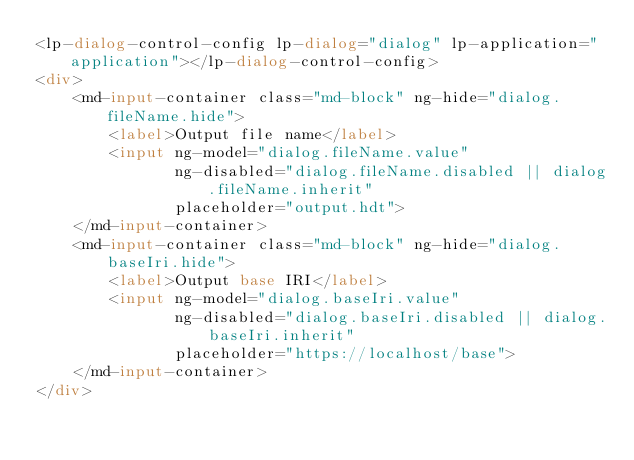<code> <loc_0><loc_0><loc_500><loc_500><_HTML_><lp-dialog-control-config lp-dialog="dialog" lp-application="application"></lp-dialog-control-config>
<div>
    <md-input-container class="md-block" ng-hide="dialog.fileName.hide">
        <label>Output file name</label>
        <input ng-model="dialog.fileName.value"
               ng-disabled="dialog.fileName.disabled || dialog.fileName.inherit"
               placeholder="output.hdt">
    </md-input-container>
    <md-input-container class="md-block" ng-hide="dialog.baseIri.hide">
        <label>Output base IRI</label>
        <input ng-model="dialog.baseIri.value"
               ng-disabled="dialog.baseIri.disabled || dialog.baseIri.inherit"
               placeholder="https://localhost/base">
    </md-input-container>
</div>
</code> 